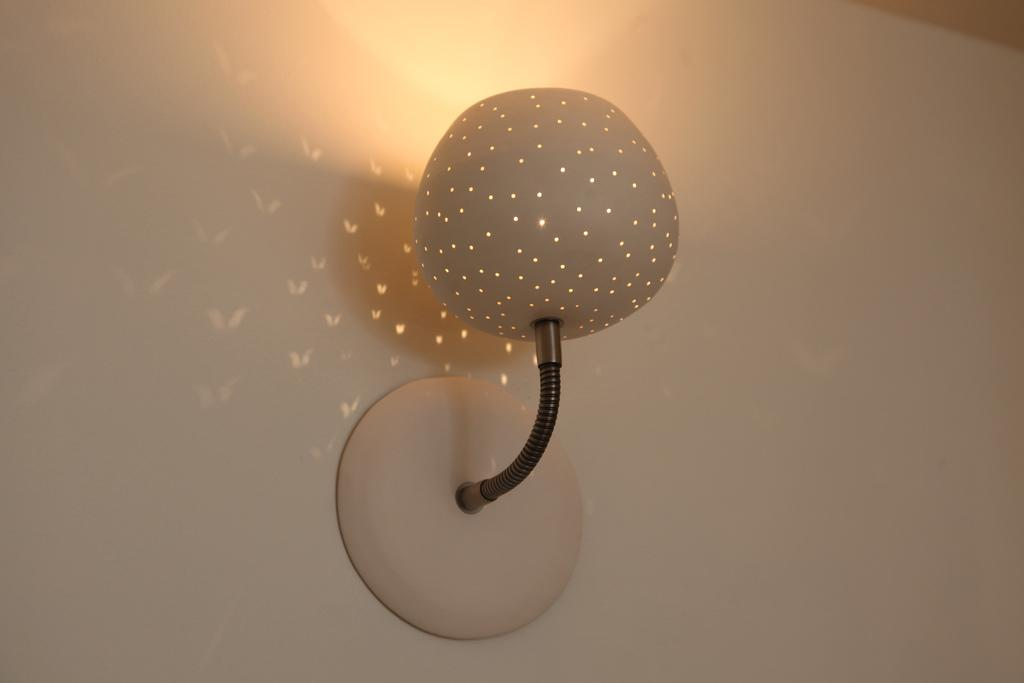What is attached to the wall in the image? There is a lamp on the wall in the image. Can you describe the lighting in the image? There are lights visible in the image. What type of shock can be seen in the image? There is no shock present in the image; it features a lamp on the wall and visible lights. 